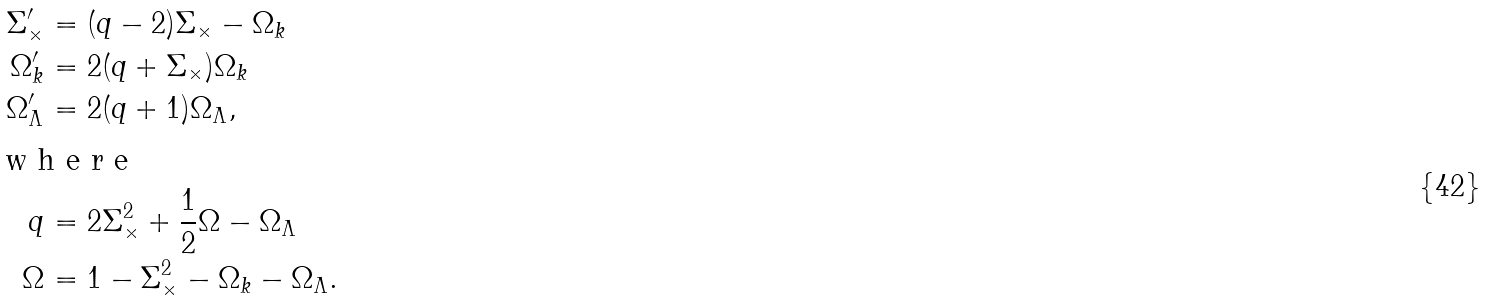<formula> <loc_0><loc_0><loc_500><loc_500>\Sigma _ { \times } ^ { \prime } & = ( q - 2 ) \Sigma _ { \times } - \Omega _ { k } \\ \Omega _ { k } ^ { \prime } & = 2 ( q + \Sigma _ { \times } ) \Omega _ { k } \\ \Omega _ { \Lambda } ^ { \prime } & = 2 ( q + 1 ) \Omega _ { \Lambda } , \intertext { w h e r e } q & = 2 \Sigma _ { \times } ^ { 2 } + \frac { 1 } { 2 } \Omega - \Omega _ { \Lambda } \\ \Omega & = 1 - \Sigma _ { \times } ^ { 2 } - \Omega _ { k } - \Omega _ { \Lambda } .</formula> 